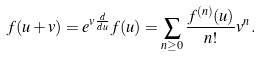Convert formula to latex. <formula><loc_0><loc_0><loc_500><loc_500>f ( u + v ) = e ^ { v \frac { d } { d u } } f ( u ) = \sum _ { n \geq 0 } \frac { f ^ { ( n ) } ( u ) } { n ! } v ^ { n } .</formula> 